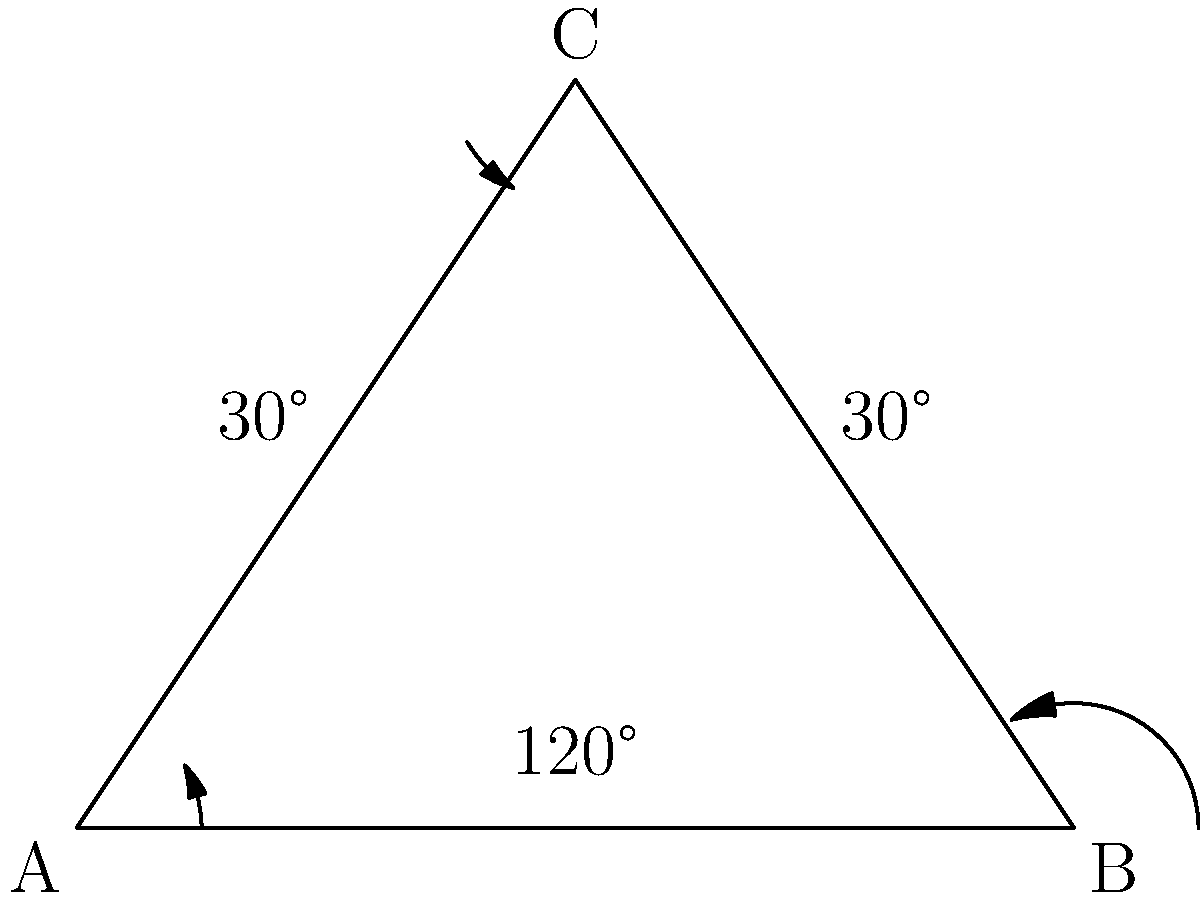As a book editor arranging a special display, you've placed two books on a shelf so their spines form a 'V' shape. The angle between the shelf and each book spine is 30°. What is the angle formed between the two book spines? Let's approach this step-by-step:

1) First, let's visualize the problem. The shelf forms the base of a triangle, and the two book spines form the other two sides.

2) We know that the angle between each book spine and the shelf is 30°. This means we have two angles of 30° in our triangle.

3) In any triangle, the sum of all interior angles is always 180°. We can express this as an equation:
   
   $30° + 30° + x = 180°$
   
   Where $x$ is the angle between the two book spines that we're trying to find.

4) Simplify the left side of the equation:
   
   $60° + x = 180°$

5) Subtract 60° from both sides:
   
   $x = 180° - 60° = 120°$

Therefore, the angle formed between the two book spines is 120°.

This problem demonstrates how understanding basic geometric principles can be applied to real-world situations, even in a field like book editing. It's a great way to encourage critical thinking and spatial reasoning in children while relating it to a familiar context.
Answer: 120° 